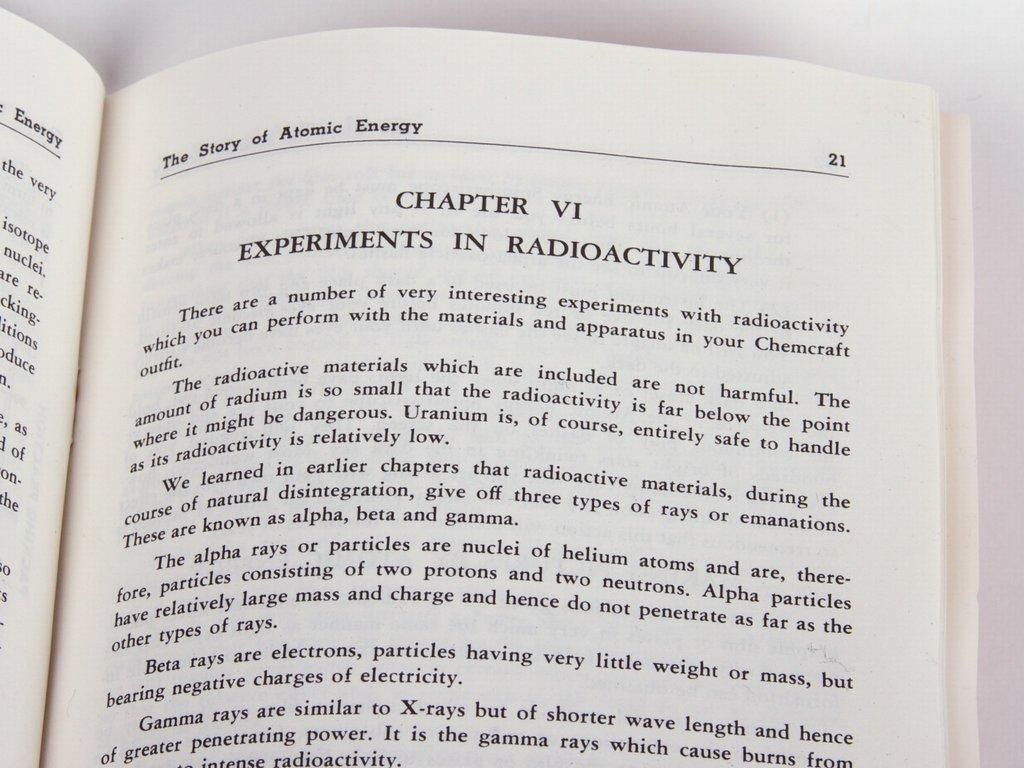<image>
Render a clear and concise summary of the photo. The book shown is turned to page 21. 